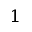Convert formula to latex. <formula><loc_0><loc_0><loc_500><loc_500>^ { 1 }</formula> 